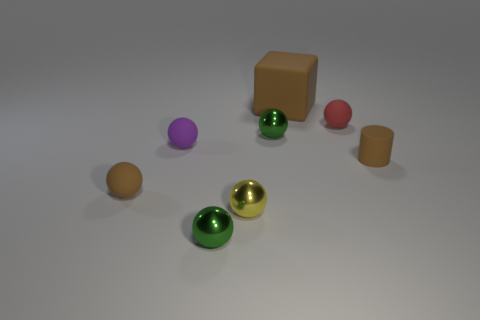Subtract all yellow spheres. How many spheres are left? 5 Subtract all green balls. How many balls are left? 4 Subtract all spheres. How many objects are left? 2 Subtract 5 spheres. How many spheres are left? 1 Add 3 yellow metallic spheres. How many yellow metallic spheres are left? 4 Add 4 large yellow spheres. How many large yellow spheres exist? 4 Add 1 red matte things. How many objects exist? 9 Subtract 1 brown cubes. How many objects are left? 7 Subtract all green blocks. Subtract all purple cylinders. How many blocks are left? 1 Subtract all red cylinders. How many gray balls are left? 0 